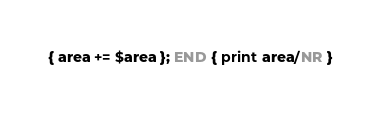Convert code to text. <code><loc_0><loc_0><loc_500><loc_500><_Awk_>{ area += $area }; END { print area/NR }
</code> 